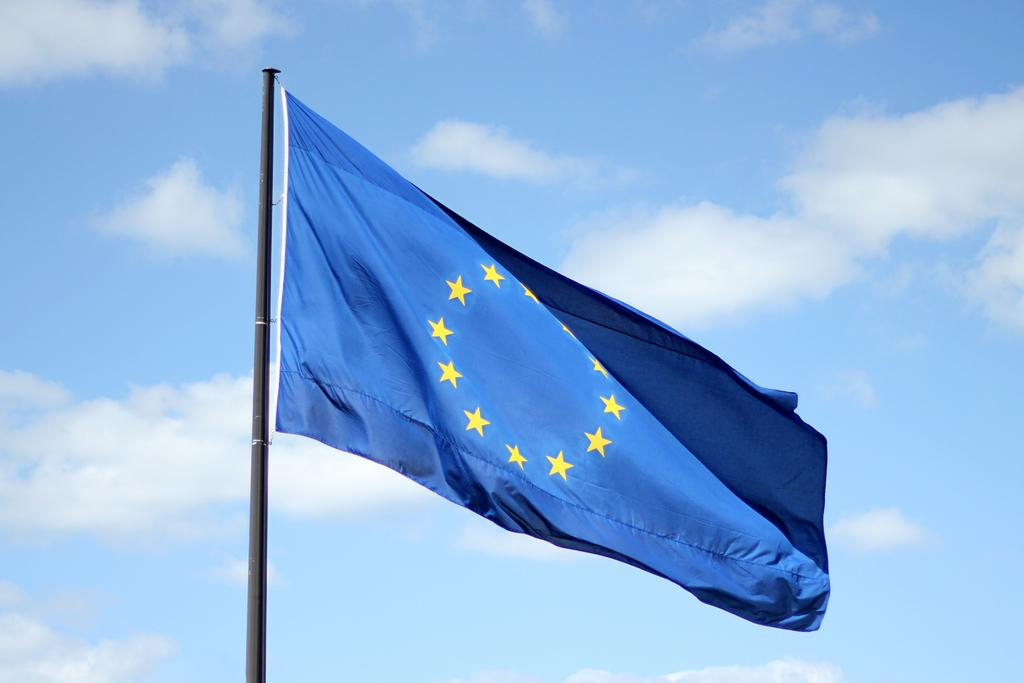What is the main subject in the center of the image? There is a blue color flag in the center of the image. What can be seen in the background of the image? There is sky visible in the background of the image. What is present in the sky? There are clouds in the sky. Are there any fairies flying around the flag in the image? There are no fairies present in the image. Can you see a worm crawling on the flag in the image? There is no worm visible on the flag in the image. 